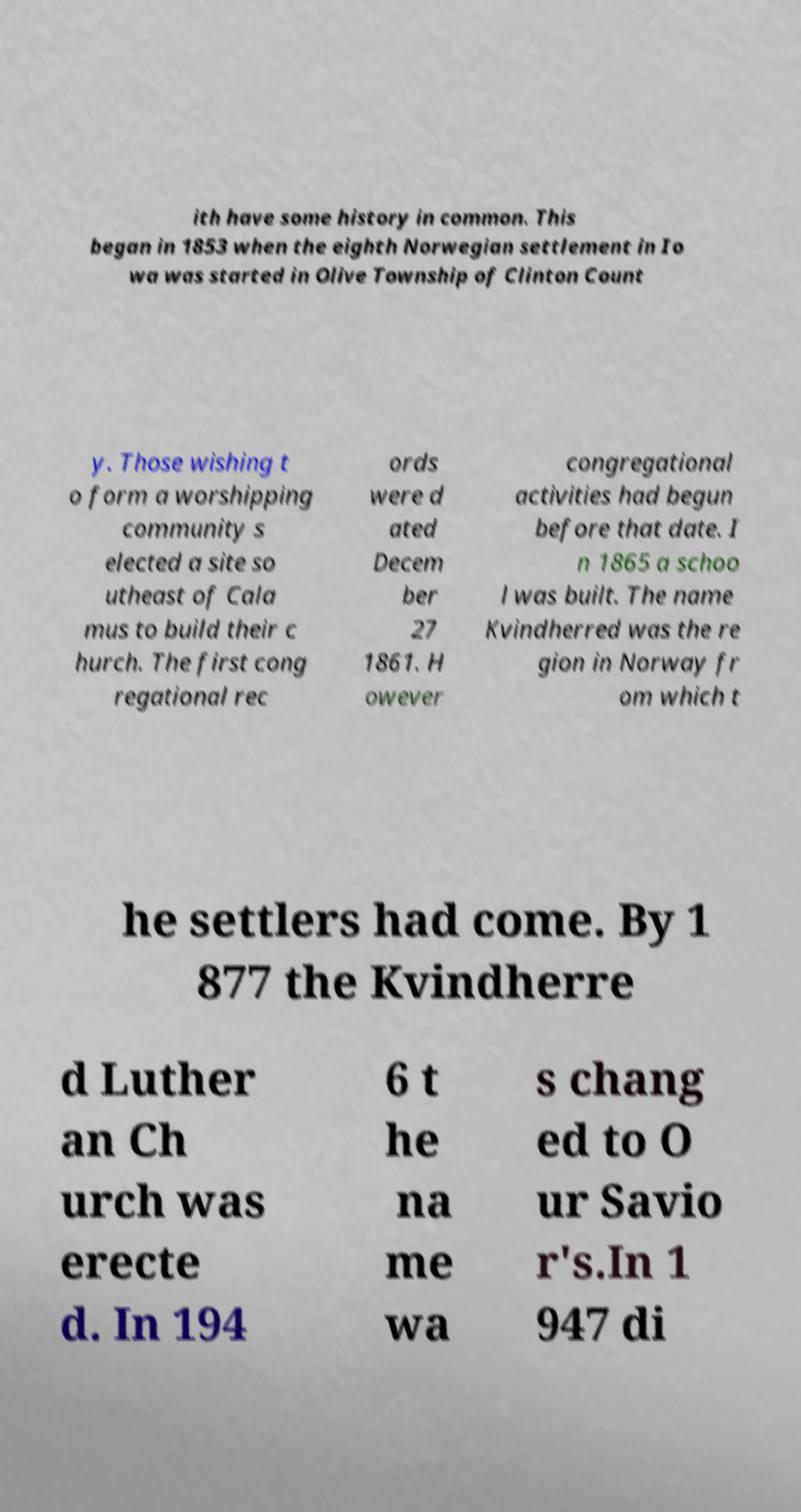Could you extract and type out the text from this image? ith have some history in common. This began in 1853 when the eighth Norwegian settlement in Io wa was started in Olive Township of Clinton Count y. Those wishing t o form a worshipping community s elected a site so utheast of Cala mus to build their c hurch. The first cong regational rec ords were d ated Decem ber 27 1861. H owever congregational activities had begun before that date. I n 1865 a schoo l was built. The name Kvindherred was the re gion in Norway fr om which t he settlers had come. By 1 877 the Kvindherre d Luther an Ch urch was erecte d. In 194 6 t he na me wa s chang ed to O ur Savio r's.In 1 947 di 